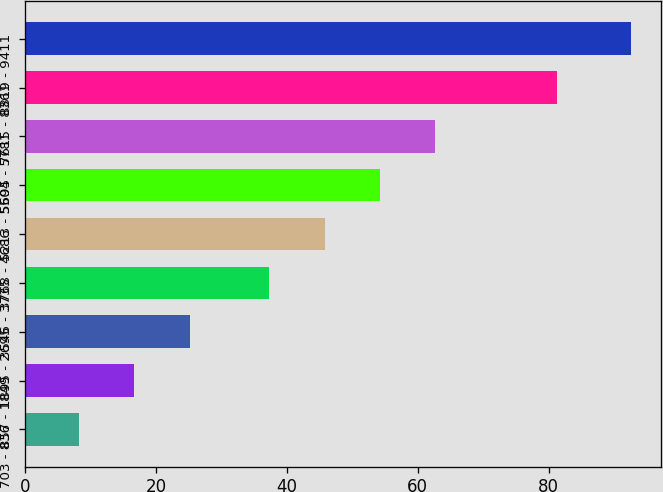<chart> <loc_0><loc_0><loc_500><loc_500><bar_chart><fcel>703 - 836<fcel>857 - 1849<fcel>1895 - 2695<fcel>3546 - 3735<fcel>3768 - 4686<fcel>5213 - 5504<fcel>5695 - 5781<fcel>7615 - 8361<fcel>8819 - 9411<nl><fcel>8.3<fcel>16.73<fcel>25.16<fcel>37.34<fcel>45.77<fcel>54.2<fcel>62.63<fcel>81.32<fcel>92.59<nl></chart> 